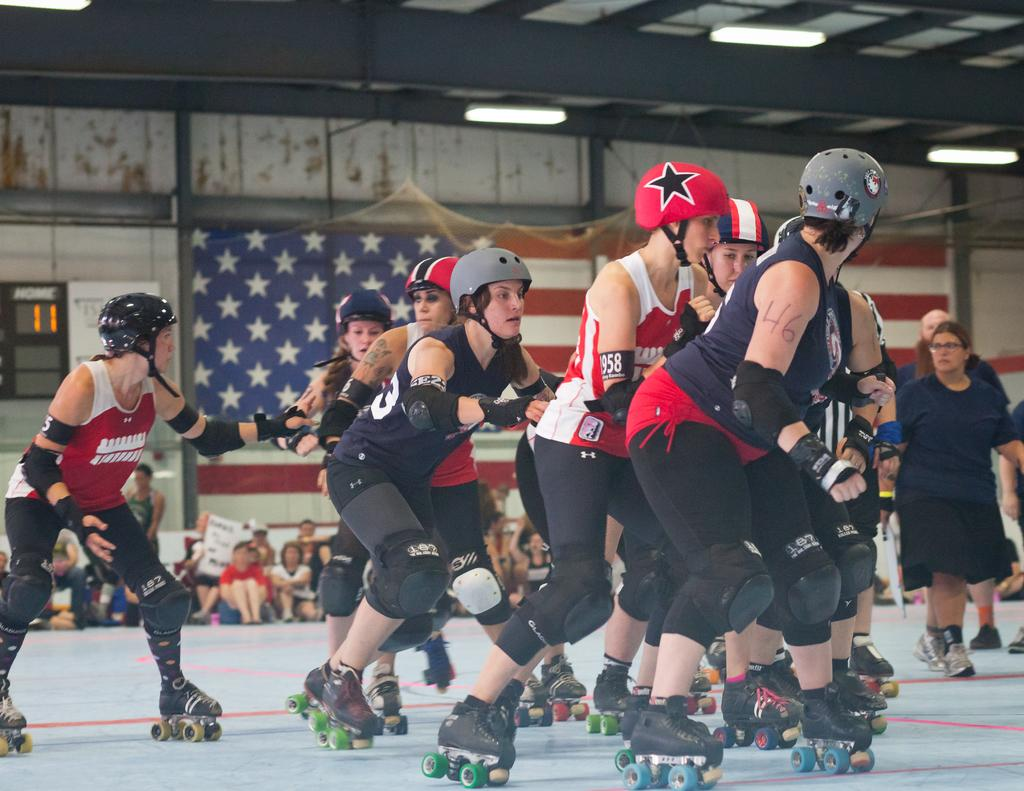What are the people in the foreground of the image doing? The people in the foreground of the image are skating. What are the people in the background of the image doing? The people in the background of the image are sitting. What objects can be seen in the background of the image? There is a net, a flag, a wall, and lights on the ceiling in the background of the image. What is the name of the nation represented by the flag in the image? There is no flag in the image that represents a specific nation, so it is not possible to determine the name of the nation. How many minutes does it take for the people to finish skating in the image? The image does not provide information about the duration of the skating activity, so it is not possible to determine how many minutes it takes for the people to finish skating. 